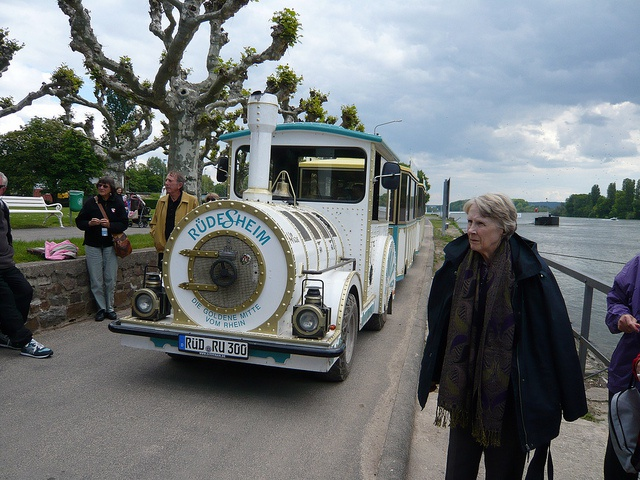Describe the objects in this image and their specific colors. I can see bus in lavender, black, darkgray, gray, and lightgray tones, people in lavender, black, gray, darkgray, and maroon tones, people in lavender, black, navy, gray, and purple tones, people in lavender, black, purple, and maroon tones, and people in lavender, black, gray, and darkgray tones in this image. 